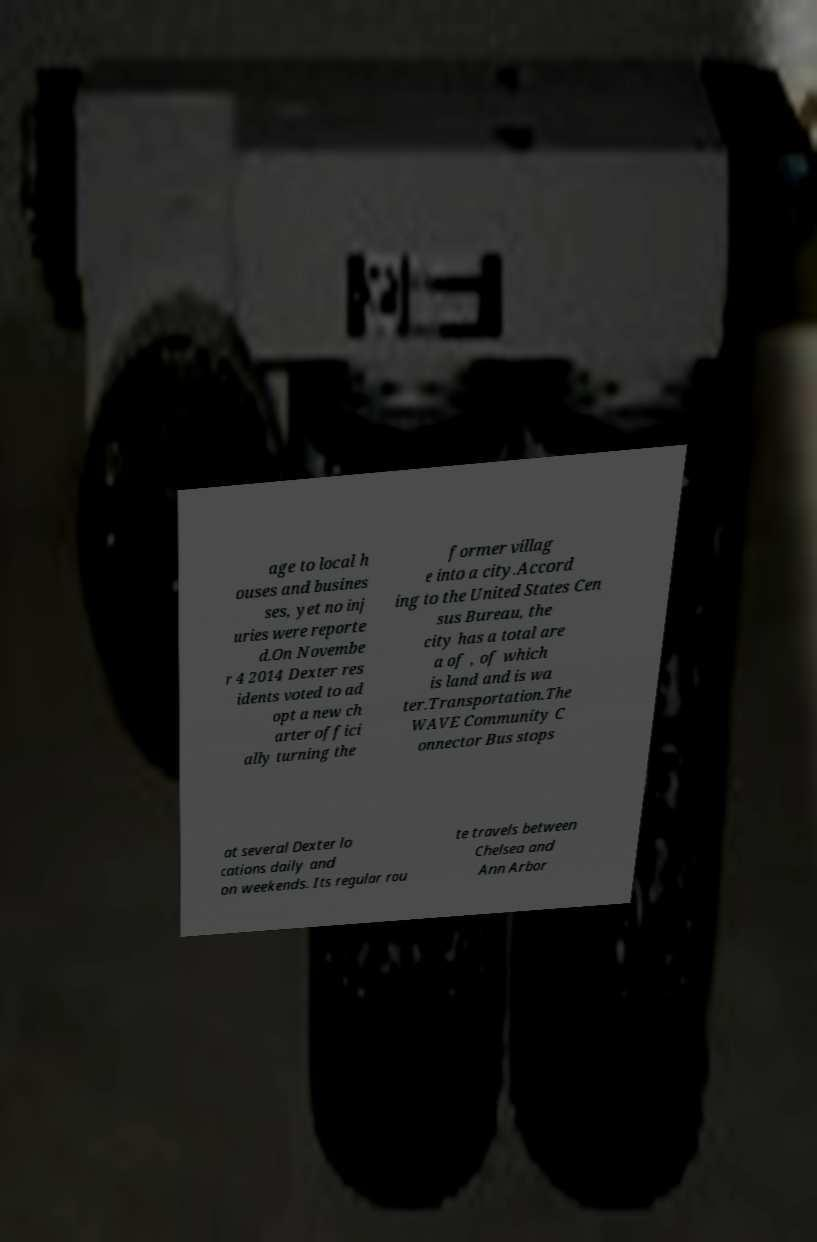Please identify and transcribe the text found in this image. age to local h ouses and busines ses, yet no inj uries were reporte d.On Novembe r 4 2014 Dexter res idents voted to ad opt a new ch arter offici ally turning the former villag e into a city.Accord ing to the United States Cen sus Bureau, the city has a total are a of , of which is land and is wa ter.Transportation.The WAVE Community C onnector Bus stops at several Dexter lo cations daily and on weekends. Its regular rou te travels between Chelsea and Ann Arbor 